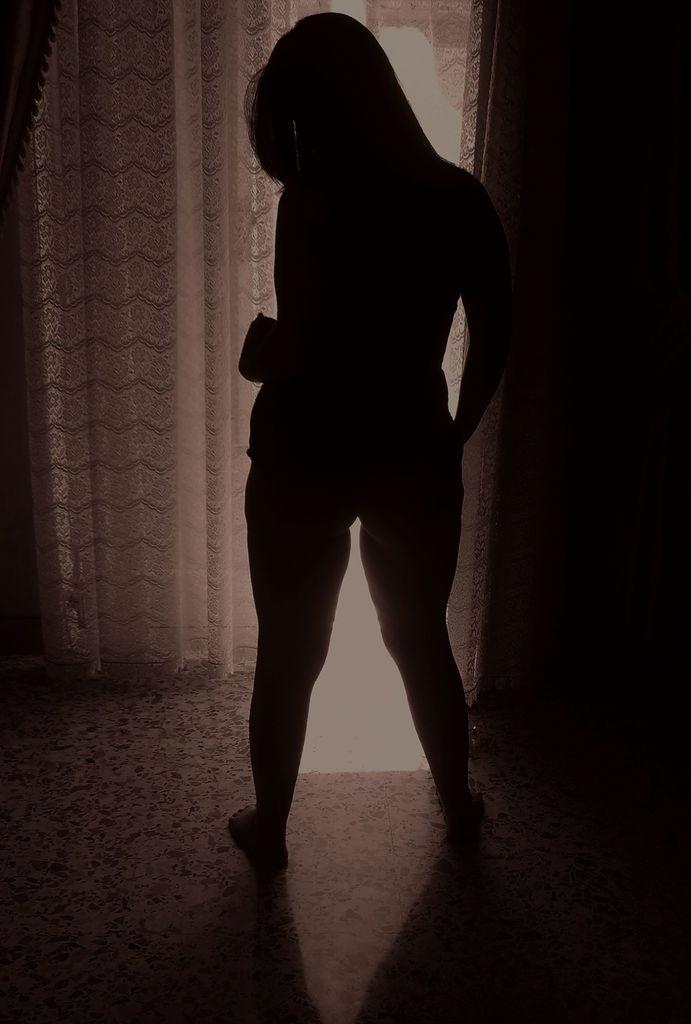What is the main subject in the image? There is a person standing in the image. What type of window treatment is present in the image? There are curtains hanging in the image. What surface is visible beneath the person in the image? There is a floor visible in the image. What type of question is the person holding in the image? There is no question visible in the image; the person is simply standing. What type of creature is present in the image? There is no creature present in the image; only a person is visible. 